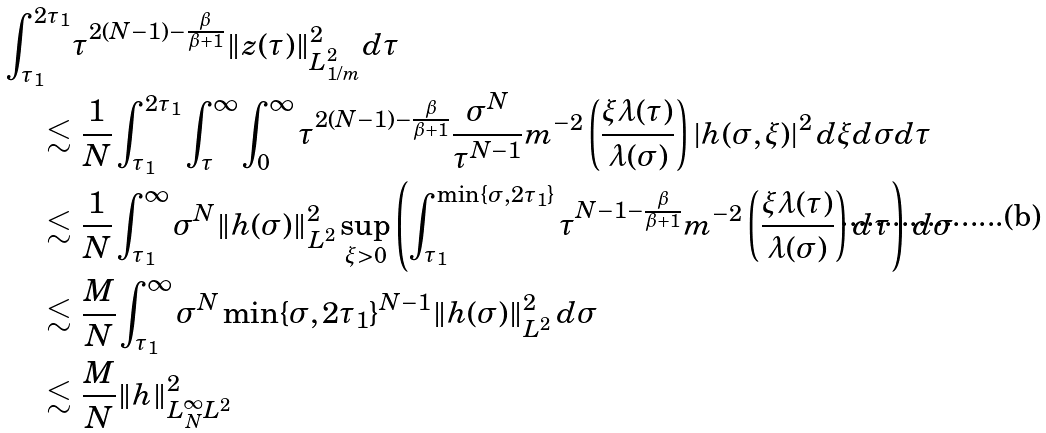<formula> <loc_0><loc_0><loc_500><loc_500>\int _ { \tau _ { 1 } } ^ { 2 \tau _ { 1 } } & \tau ^ { 2 ( N - 1 ) - \frac { \beta } { \beta + 1 } } \| z ( \tau ) \| _ { L ^ { 2 } _ { 1 / m } } ^ { 2 } d \tau \\ \lesssim & \ \frac { 1 } { N } \int _ { \tau _ { 1 } } ^ { 2 \tau _ { 1 } } \int _ { \tau } ^ { \infty } \int _ { 0 } ^ { \infty } \tau ^ { 2 ( N - 1 ) - \frac { \beta } { \beta + 1 } } \frac { \sigma ^ { N } } { \tau ^ { N - 1 } } m ^ { - 2 } \left ( \frac { \xi \lambda ( \tau ) } { \lambda ( \sigma ) } \right ) | h ( \sigma , \xi ) | ^ { 2 } \, d \xi d \sigma d \tau \\ \lesssim & \ \frac { 1 } { N } \int _ { \tau _ { 1 } } ^ { \infty } \sigma ^ { N } \| h ( \sigma ) \| _ { L ^ { 2 } } ^ { 2 } \sup _ { \xi > 0 } \left ( \int _ { \tau _ { 1 } } ^ { \min \{ \sigma , 2 \tau _ { 1 } \} } \tau ^ { N - 1 - \frac { \beta } { \beta + 1 } } m ^ { - 2 } \left ( \frac { \xi \lambda ( \tau ) } { \lambda ( \sigma ) } \right ) d \tau \right ) \, d \sigma \\ \lesssim & \ \frac { M } { N } \int _ { \tau _ { 1 } } ^ { \infty } \sigma ^ { N } \min \{ \sigma , 2 \tau _ { 1 } \} ^ { N - 1 } \| h ( \sigma ) \| _ { L ^ { 2 } } ^ { 2 } \, d \sigma \\ \lesssim & \ \frac { M } { N } \| h \| _ { L ^ { \infty } _ { N } L ^ { 2 } } ^ { 2 }</formula> 